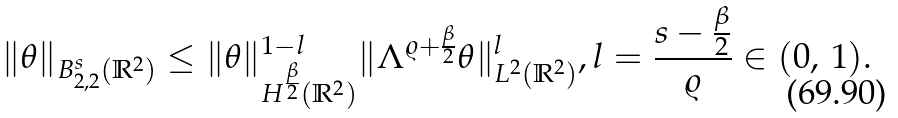<formula> <loc_0><loc_0><loc_500><loc_500>\| \theta \| _ { { B } _ { 2 , 2 } ^ { s } ( \mathbb { R } ^ { 2 } ) } \leq \| \theta \| _ { H ^ { \frac { \beta } { 2 } } ( \mathbb { R } ^ { 2 } ) } ^ { 1 - l } \| \Lambda ^ { \varrho + \frac { \beta } { 2 } } \theta \| _ { L ^ { 2 } ( \mathbb { R } ^ { 2 } ) } ^ { l } , l = \frac { s - \frac { \beta } { 2 } } { \varrho } \in ( 0 , \, 1 ) .</formula> 